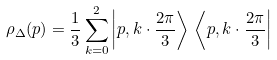Convert formula to latex. <formula><loc_0><loc_0><loc_500><loc_500>\rho _ { \Delta } ( p ) = \frac { 1 } { 3 } \sum _ { k = 0 } ^ { 2 } \left | p , k \cdot \frac { 2 \pi } { 3 } \right > \, \left < p , k \cdot \frac { 2 \pi } { 3 } \right |</formula> 